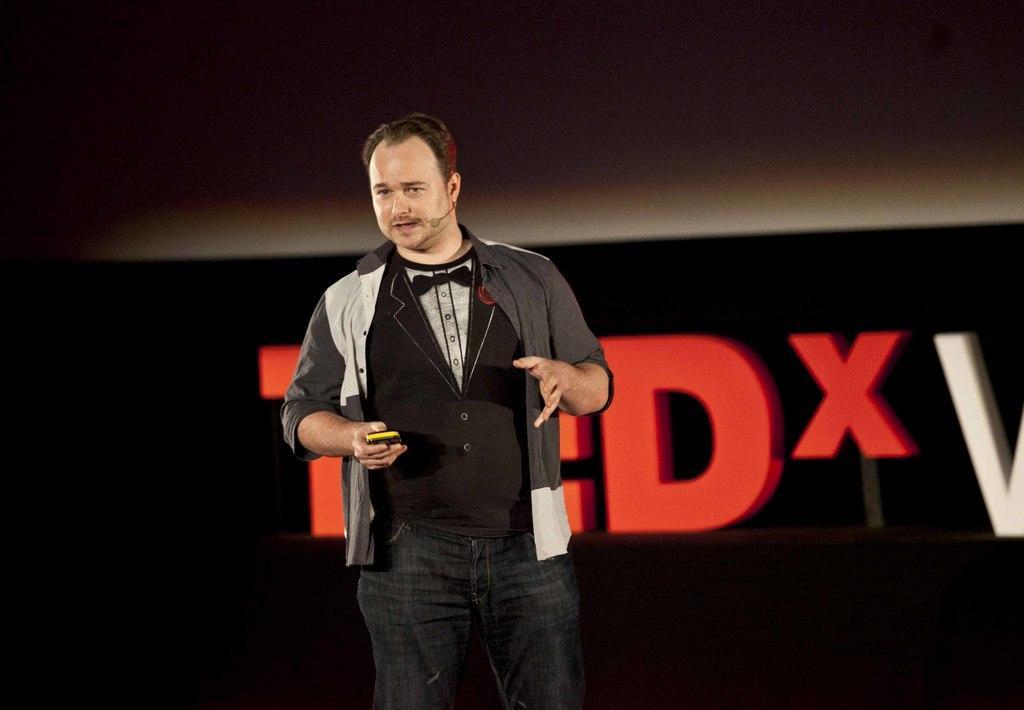Can you describe this image briefly? In this image I can see a man is standing and holding an object in the hand. The man is wearing a microphone, pant and other type of clothes. In the background I can see some name. 